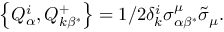Convert formula to latex. <formula><loc_0><loc_0><loc_500><loc_500>\left \{ Q _ { \alpha } ^ { i } , Q _ { k \beta ^ { * } } ^ { + } \right \} = 1 / 2 \delta _ { k } ^ { i } \sigma _ { \alpha \beta ^ { * } } ^ { \mu } \widetilde { \sigma } _ { \mu } .</formula> 